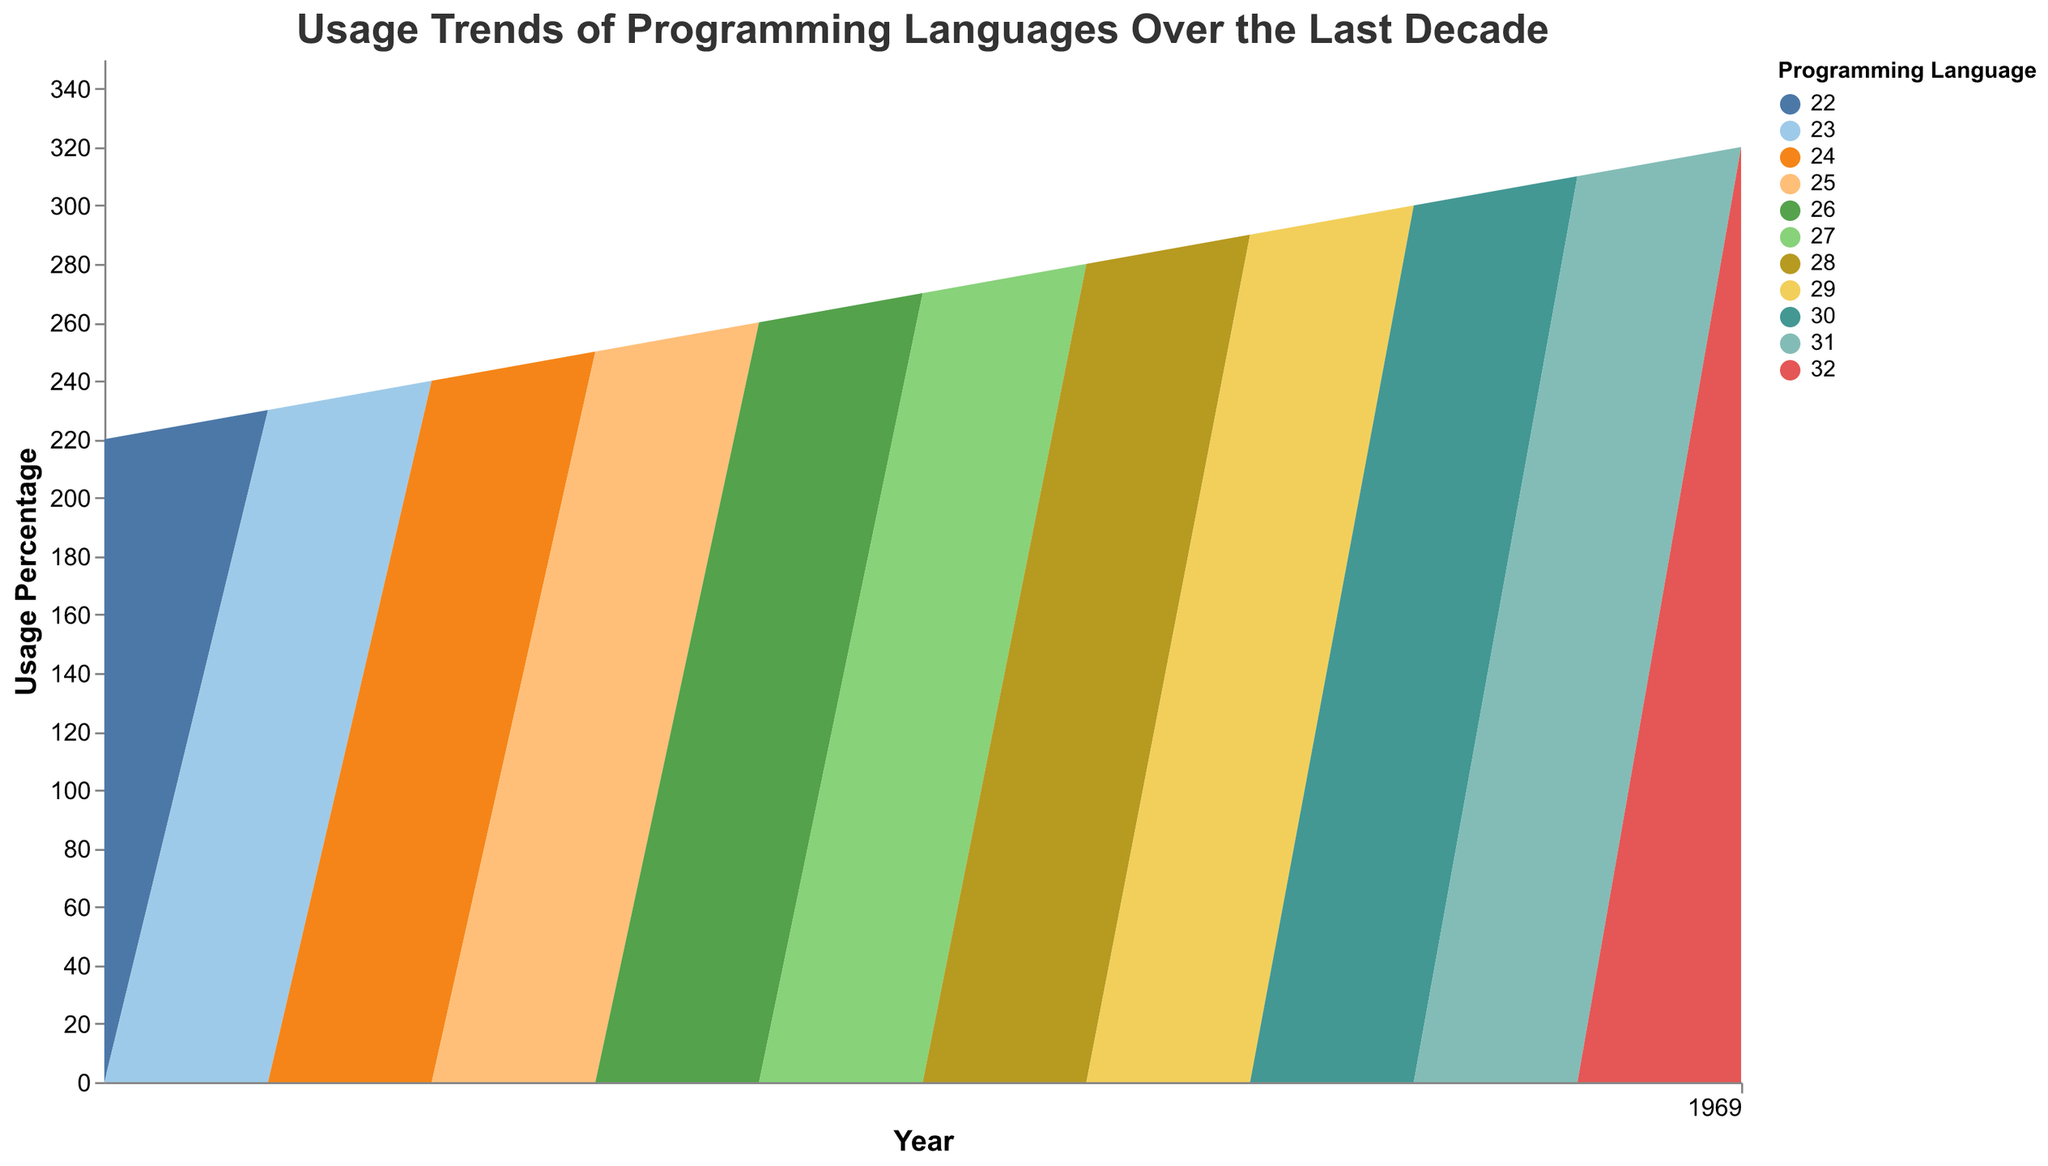What's the title of the stream graph? The title is usually at the top of a figure. Look at the top center of the figure to read it.
Answer: Usage Trends of Programming Languages Over the Last Decade What is the overall trend of JavaScript usage from 2013 to 2023? Observe the area representing JavaScript over the years in the stream graph. Notice the increase in width from 2013 to 2023.
Answer: Increasing Which year shows the highest percentage usage for Python? Look for the year where the Python area reaches its maximum height by referring to the stream color corresponding to Python.
Answer: 2023 Compare the trends of PHP and TypeScript from 2016 to 2023. Observe the stream areas for PHP and TypeScript from 2016 to 2023. PHP shows a declining trend, while TypeScript shows a rising trend.
Answer: PHP decreases, TypeScript increases What is the percentage usage difference between JavaScript and Python in 2023? Look at the heights of JavaScript and Python in the stream graph for the year 2023, then subtract the percentage of Python from JavaScript.
Answer: 6% Which programming language showed the most rapid increase in usage from 2016 to 2023? Compare the slopes of the stream areas for different languages between 2016 and 2023. TypeScript's slope is the steepest, indicating the most rapid increase.
Answer: TypeScript By how much did Go's usage increase from 2013 to 2023? Find the percentage value for Go in 2013 and 2023, then calculate the difference between 2023 and 2013.
Answer: 7% Which three programming languages had the lowest usage in 2013? Examine the bottommost areas in the stream graph for 2013 and order them by size.
Answer: Swift, Kotlin, TypeScript How did Ruby's percentage change from 2013 to 2023? Look at the stream for Ruby and note its height in 2013 and 2023, then calculate the difference.
Answer: Decreased by 7% What can you infer about trends in Swift usage over the years? Observe the stream area representing Swift from its introduction to 2023. You see a consistent increase over the years.
Answer: Consistently increasing 